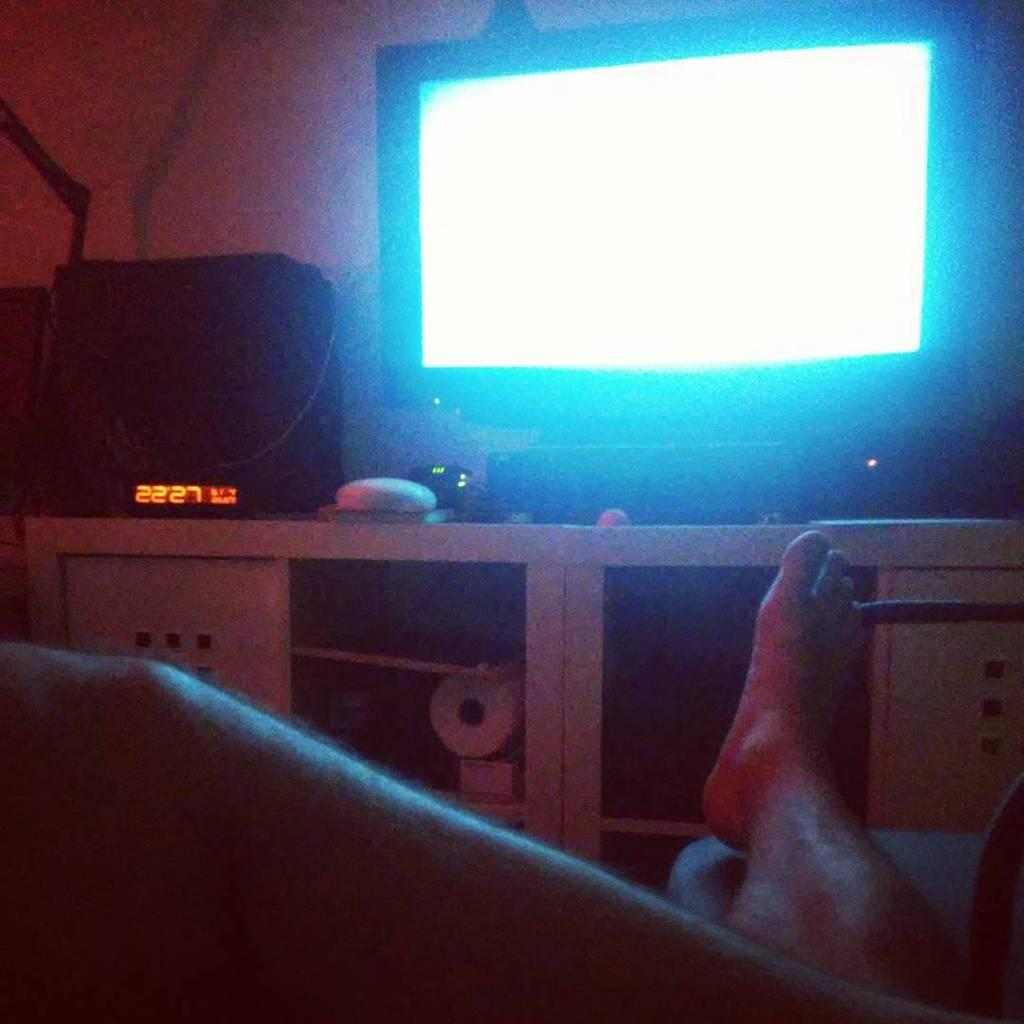<image>
Write a terse but informative summary of the picture. A stand with a TV and a black box that reads 22 27. 